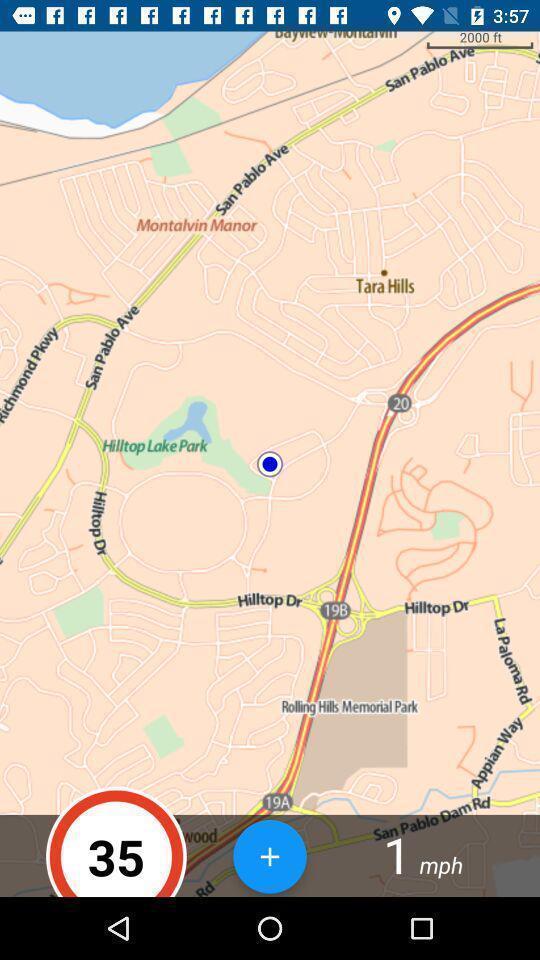Summarize the information in this screenshot. Page of location finder app. 